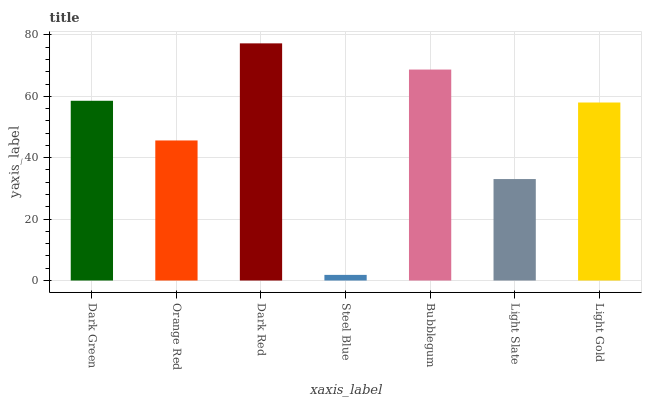Is Steel Blue the minimum?
Answer yes or no. Yes. Is Dark Red the maximum?
Answer yes or no. Yes. Is Orange Red the minimum?
Answer yes or no. No. Is Orange Red the maximum?
Answer yes or no. No. Is Dark Green greater than Orange Red?
Answer yes or no. Yes. Is Orange Red less than Dark Green?
Answer yes or no. Yes. Is Orange Red greater than Dark Green?
Answer yes or no. No. Is Dark Green less than Orange Red?
Answer yes or no. No. Is Light Gold the high median?
Answer yes or no. Yes. Is Light Gold the low median?
Answer yes or no. Yes. Is Dark Red the high median?
Answer yes or no. No. Is Steel Blue the low median?
Answer yes or no. No. 